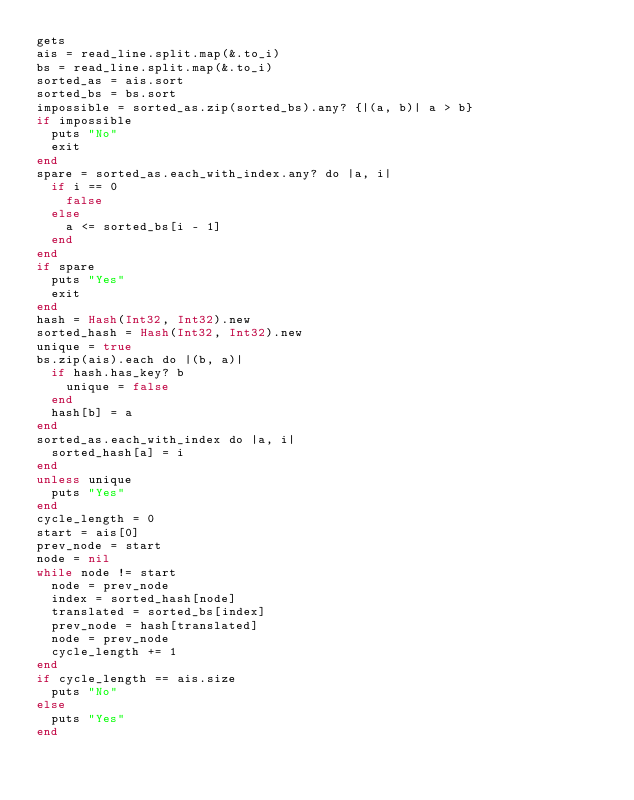<code> <loc_0><loc_0><loc_500><loc_500><_Crystal_>gets
ais = read_line.split.map(&.to_i)
bs = read_line.split.map(&.to_i)
sorted_as = ais.sort
sorted_bs = bs.sort
impossible = sorted_as.zip(sorted_bs).any? {|(a, b)| a > b}
if impossible
  puts "No"
  exit
end
spare = sorted_as.each_with_index.any? do |a, i|
  if i == 0
    false
  else
    a <= sorted_bs[i - 1]
  end
end
if spare
  puts "Yes"
  exit
end
hash = Hash(Int32, Int32).new
sorted_hash = Hash(Int32, Int32).new
unique = true
bs.zip(ais).each do |(b, a)|
  if hash.has_key? b
    unique = false
  end
  hash[b] = a
end
sorted_as.each_with_index do |a, i|
  sorted_hash[a] = i
end
unless unique
  puts "Yes"
end
cycle_length = 0
start = ais[0]
prev_node = start
node = nil
while node != start
  node = prev_node
  index = sorted_hash[node]
  translated = sorted_bs[index]
  prev_node = hash[translated]
  node = prev_node
  cycle_length += 1
end
if cycle_length == ais.size
  puts "No"
else
  puts "Yes"
end
</code> 